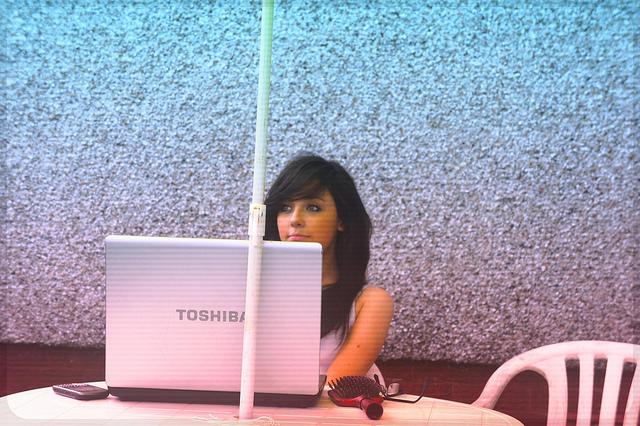Where is the plastic chair?
Quick response, please. Right. Is she a beautician?
Short answer required. No. What kind of computer is this?
Give a very brief answer. Toshiba. 